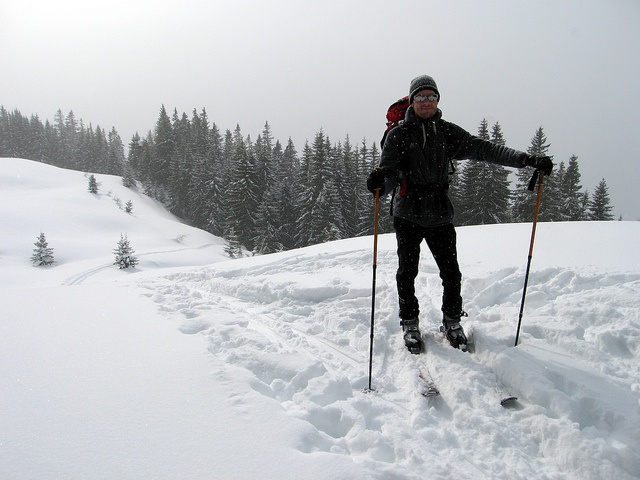Describe the objects in this image and their specific colors. I can see people in white, black, gray, lightgray, and darkgray tones, skis in white, darkgray, lightgray, and gray tones, and backpack in white, black, maroon, gray, and darkgray tones in this image. 